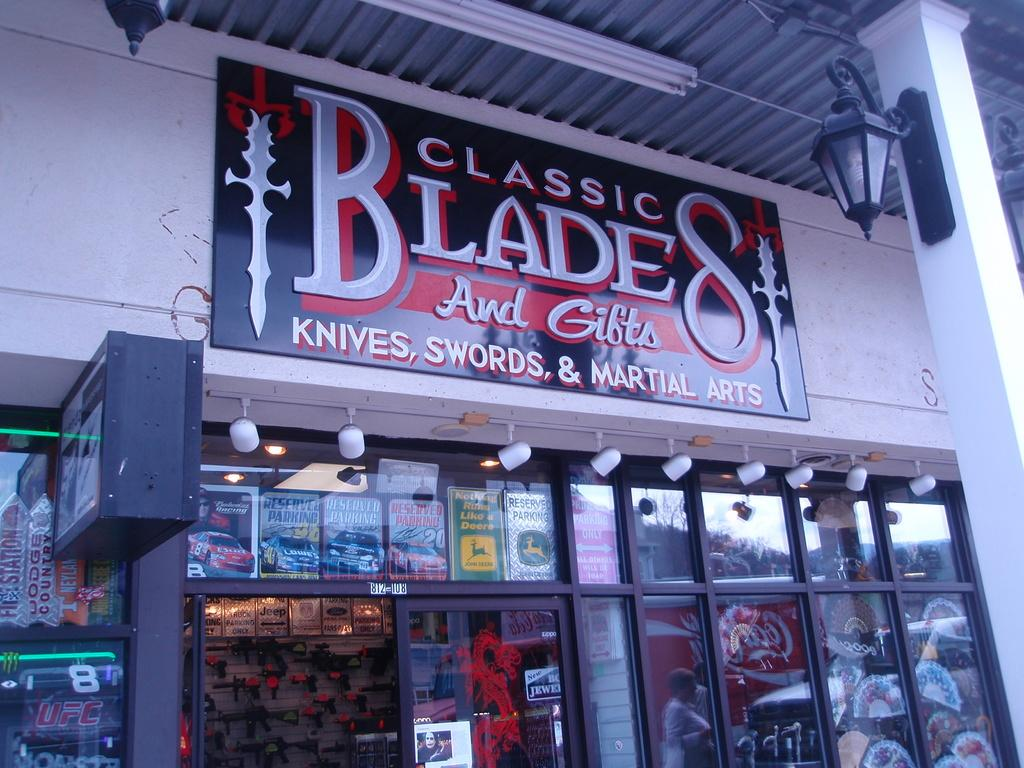<image>
Describe the image concisely. A store with an open door that sells swords. 